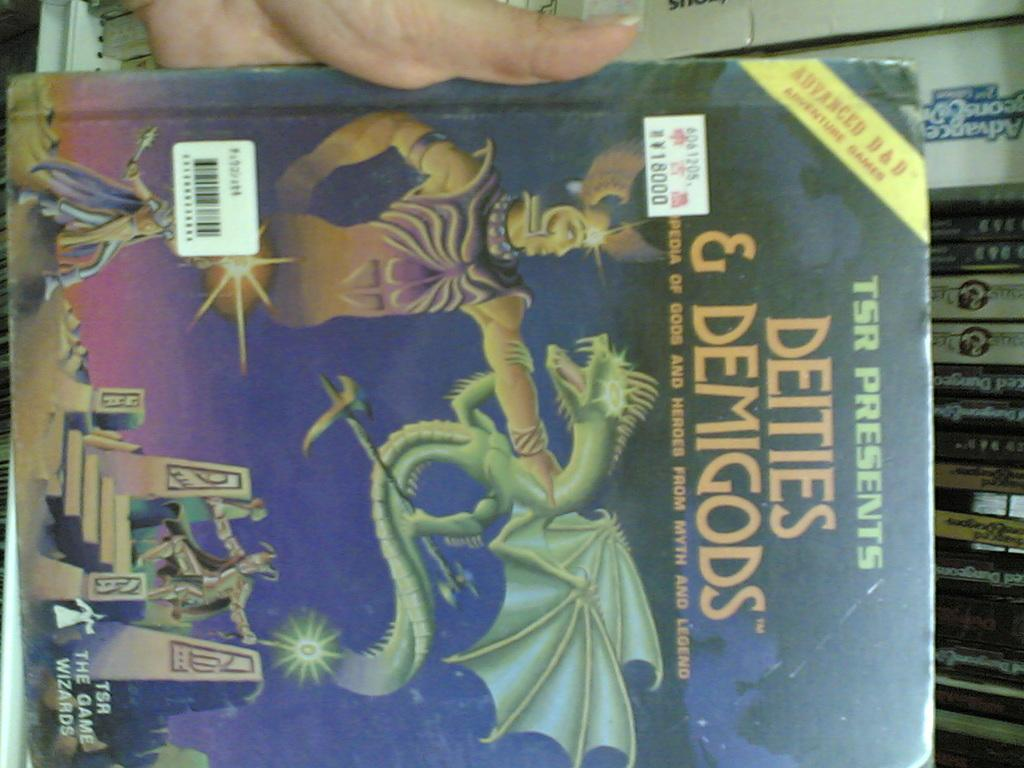Provide a one-sentence caption for the provided image. The title of this book is Deities and Demigods. 